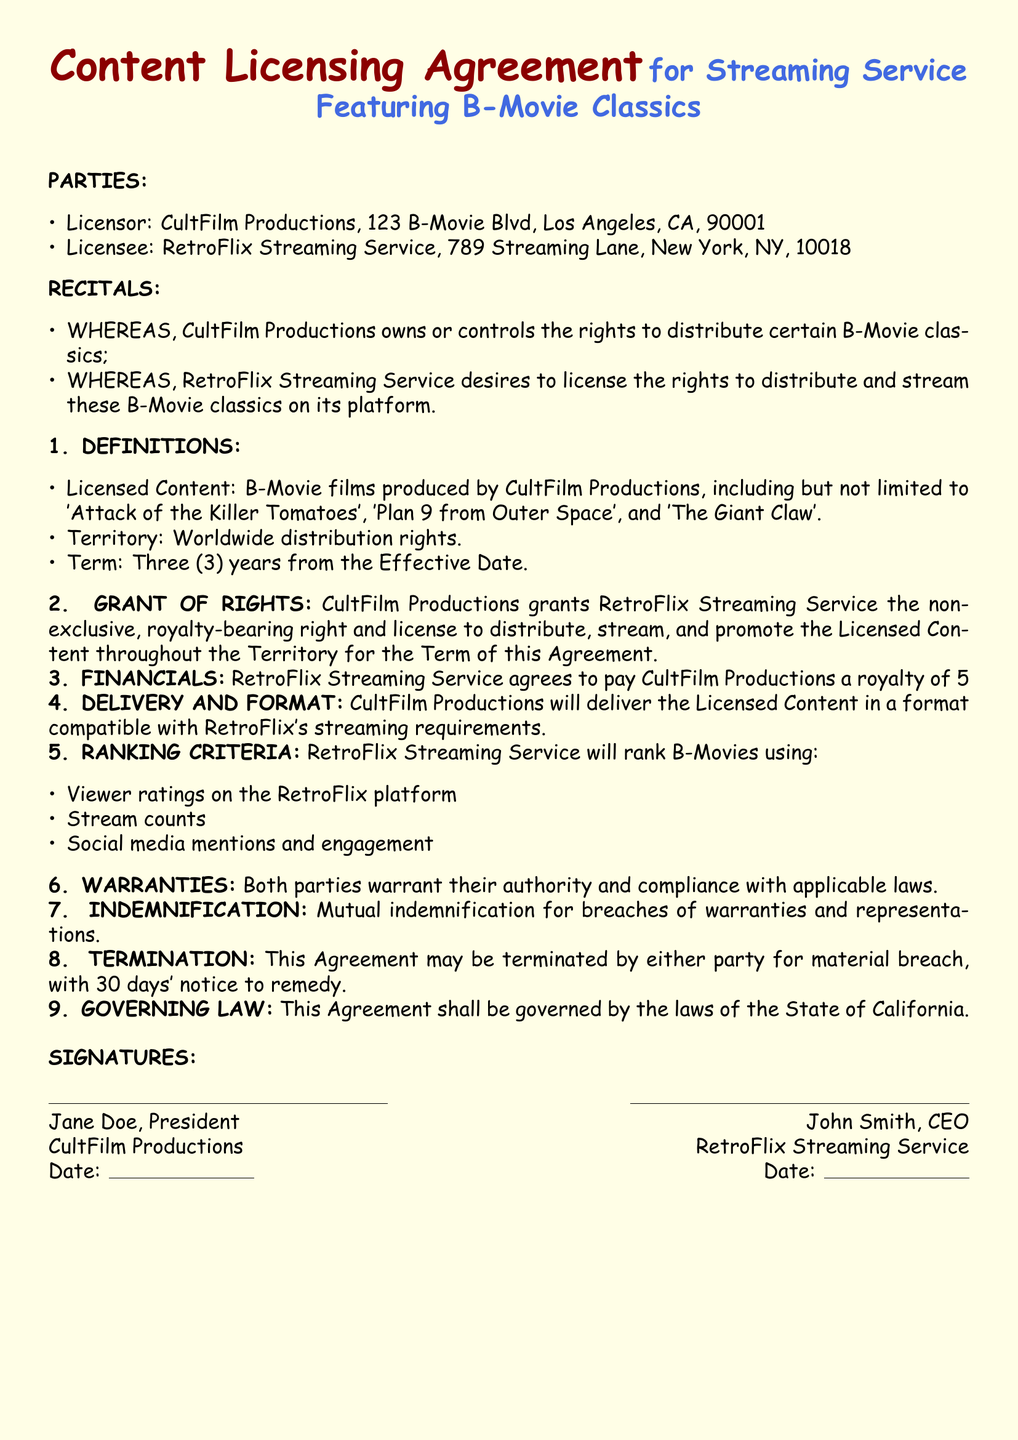What is the name of the Licensor? The Licensor is identified in the document as CultFilm Productions.
Answer: CultFilm Productions What is the royalty percentage that RetroFlix must pay? The document states that RetroFlix Streaming Service agrees to pay a royalty of 5% of net revenues.
Answer: 5% What is the Term of the Agreement? The Term is specified as three years from the Effective Date.
Answer: Three years What are the three criteria used by RetroFlix for ranking B-Movies? The document outlines viewer ratings, stream counts, and social media mentions and engagement as the ranking criteria.
Answer: Viewer ratings, stream counts, and social media mentions What is the governing law of this Agreement? The governing law is specified in the document as the laws of the State of California.
Answer: California How many days' notice is required to terminate the Agreement? The document specifies that 30 days' notice is required for termination due to material breach.
Answer: 30 days What type of agreement is this document? The document explicitly states that it is a Content Licensing Agreement for a streaming service.
Answer: Content Licensing Agreement What is the address of the Licensee? The Licensee's address is included in the document as 789 Streaming Lane, New York, NY, 10018.
Answer: 789 Streaming Lane, New York, NY, 10018 What does CultFilm Productions warrant in the Agreement? Both parties warrant their authority and compliance with applicable laws as stated in the document.
Answer: Authority and compliance with applicable laws 